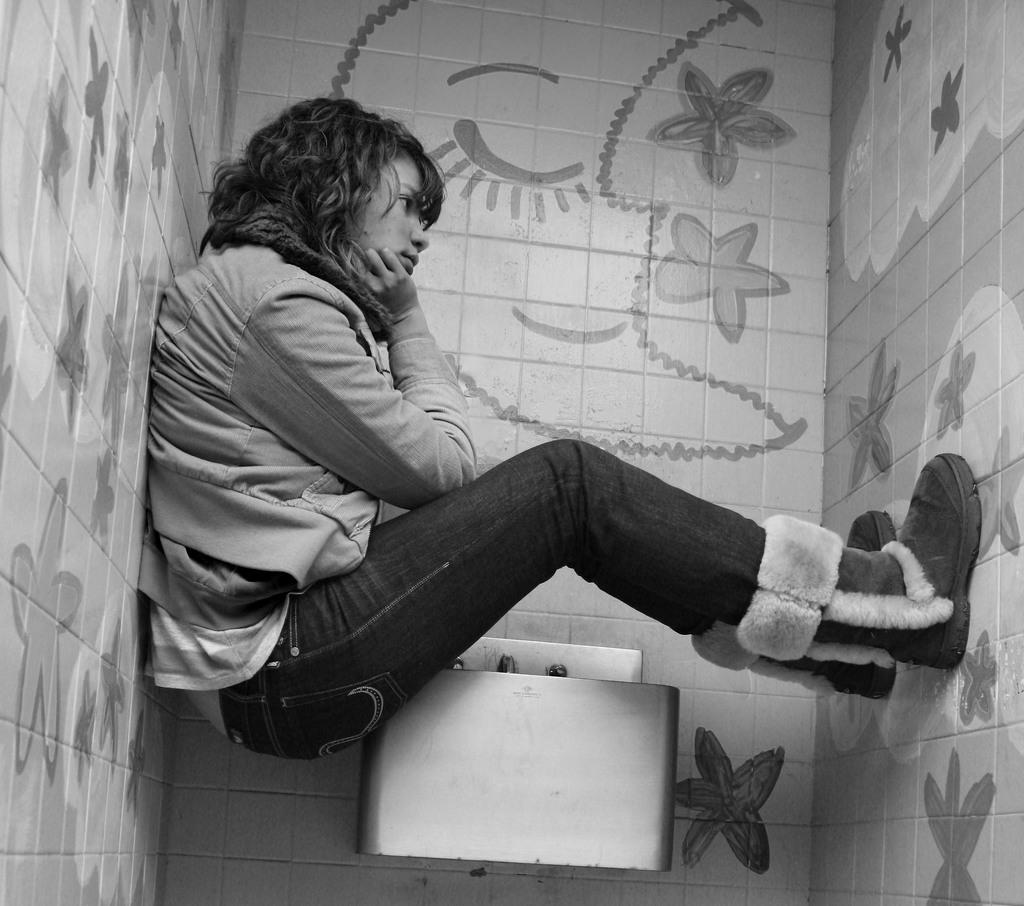What is the color scheme of the image? The image is black and white. Can you describe the main subject in the image? There is a lady in the image. What is the lady doing in the image? The lady is sitting on a sink. What type of background can be seen in the image? There are walls visible in the image. How many ducks are swimming in the sink with the lady? There are no ducks present in the image. What word is written on the wall in the image? There is no word written on the wall in the image. 